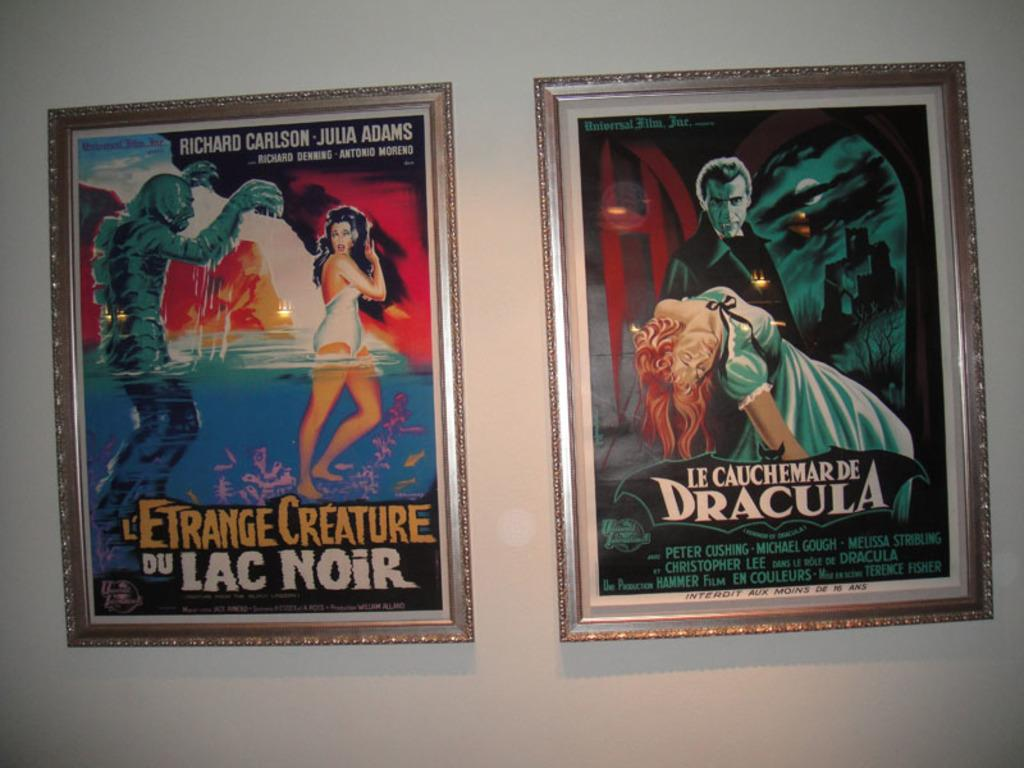<image>
Provide a brief description of the given image. Two posters for Creature from the Black Lagoon and Dracula. 